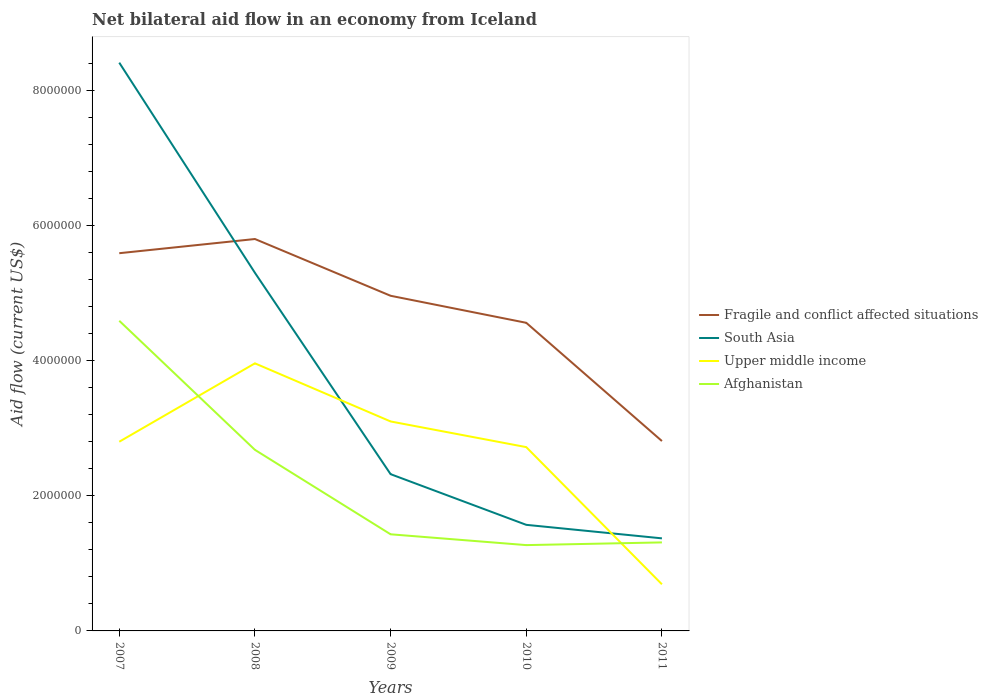How many different coloured lines are there?
Offer a terse response. 4. Does the line corresponding to South Asia intersect with the line corresponding to Fragile and conflict affected situations?
Offer a very short reply. Yes. Is the number of lines equal to the number of legend labels?
Keep it short and to the point. Yes. Across all years, what is the maximum net bilateral aid flow in Upper middle income?
Offer a very short reply. 6.90e+05. In which year was the net bilateral aid flow in Afghanistan maximum?
Ensure brevity in your answer.  2010. What is the total net bilateral aid flow in South Asia in the graph?
Give a very brief answer. 6.09e+06. What is the difference between the highest and the second highest net bilateral aid flow in South Asia?
Your answer should be compact. 7.04e+06. Is the net bilateral aid flow in Fragile and conflict affected situations strictly greater than the net bilateral aid flow in South Asia over the years?
Keep it short and to the point. No. How many lines are there?
Give a very brief answer. 4. How many years are there in the graph?
Keep it short and to the point. 5. Are the values on the major ticks of Y-axis written in scientific E-notation?
Ensure brevity in your answer.  No. Does the graph contain any zero values?
Offer a very short reply. No. Does the graph contain grids?
Your response must be concise. No. Where does the legend appear in the graph?
Ensure brevity in your answer.  Center right. How many legend labels are there?
Your answer should be very brief. 4. What is the title of the graph?
Your answer should be very brief. Net bilateral aid flow in an economy from Iceland. What is the label or title of the Y-axis?
Your response must be concise. Aid flow (current US$). What is the Aid flow (current US$) of Fragile and conflict affected situations in 2007?
Keep it short and to the point. 5.59e+06. What is the Aid flow (current US$) in South Asia in 2007?
Provide a short and direct response. 8.41e+06. What is the Aid flow (current US$) in Upper middle income in 2007?
Provide a succinct answer. 2.80e+06. What is the Aid flow (current US$) in Afghanistan in 2007?
Offer a very short reply. 4.59e+06. What is the Aid flow (current US$) in Fragile and conflict affected situations in 2008?
Your answer should be very brief. 5.80e+06. What is the Aid flow (current US$) of South Asia in 2008?
Keep it short and to the point. 5.30e+06. What is the Aid flow (current US$) in Upper middle income in 2008?
Your response must be concise. 3.96e+06. What is the Aid flow (current US$) in Afghanistan in 2008?
Keep it short and to the point. 2.68e+06. What is the Aid flow (current US$) of Fragile and conflict affected situations in 2009?
Offer a very short reply. 4.96e+06. What is the Aid flow (current US$) of South Asia in 2009?
Your answer should be very brief. 2.32e+06. What is the Aid flow (current US$) of Upper middle income in 2009?
Your response must be concise. 3.10e+06. What is the Aid flow (current US$) of Afghanistan in 2009?
Provide a short and direct response. 1.43e+06. What is the Aid flow (current US$) of Fragile and conflict affected situations in 2010?
Your response must be concise. 4.56e+06. What is the Aid flow (current US$) of South Asia in 2010?
Offer a very short reply. 1.57e+06. What is the Aid flow (current US$) in Upper middle income in 2010?
Keep it short and to the point. 2.72e+06. What is the Aid flow (current US$) in Afghanistan in 2010?
Your answer should be very brief. 1.27e+06. What is the Aid flow (current US$) in Fragile and conflict affected situations in 2011?
Keep it short and to the point. 2.81e+06. What is the Aid flow (current US$) in South Asia in 2011?
Keep it short and to the point. 1.37e+06. What is the Aid flow (current US$) in Upper middle income in 2011?
Keep it short and to the point. 6.90e+05. What is the Aid flow (current US$) in Afghanistan in 2011?
Provide a succinct answer. 1.31e+06. Across all years, what is the maximum Aid flow (current US$) in Fragile and conflict affected situations?
Offer a terse response. 5.80e+06. Across all years, what is the maximum Aid flow (current US$) in South Asia?
Provide a succinct answer. 8.41e+06. Across all years, what is the maximum Aid flow (current US$) of Upper middle income?
Give a very brief answer. 3.96e+06. Across all years, what is the maximum Aid flow (current US$) of Afghanistan?
Your answer should be compact. 4.59e+06. Across all years, what is the minimum Aid flow (current US$) in Fragile and conflict affected situations?
Provide a succinct answer. 2.81e+06. Across all years, what is the minimum Aid flow (current US$) in South Asia?
Ensure brevity in your answer.  1.37e+06. Across all years, what is the minimum Aid flow (current US$) of Upper middle income?
Your response must be concise. 6.90e+05. Across all years, what is the minimum Aid flow (current US$) of Afghanistan?
Ensure brevity in your answer.  1.27e+06. What is the total Aid flow (current US$) of Fragile and conflict affected situations in the graph?
Your answer should be compact. 2.37e+07. What is the total Aid flow (current US$) of South Asia in the graph?
Offer a very short reply. 1.90e+07. What is the total Aid flow (current US$) of Upper middle income in the graph?
Make the answer very short. 1.33e+07. What is the total Aid flow (current US$) of Afghanistan in the graph?
Provide a succinct answer. 1.13e+07. What is the difference between the Aid flow (current US$) of South Asia in 2007 and that in 2008?
Your answer should be very brief. 3.11e+06. What is the difference between the Aid flow (current US$) of Upper middle income in 2007 and that in 2008?
Ensure brevity in your answer.  -1.16e+06. What is the difference between the Aid flow (current US$) of Afghanistan in 2007 and that in 2008?
Make the answer very short. 1.91e+06. What is the difference between the Aid flow (current US$) of Fragile and conflict affected situations in 2007 and that in 2009?
Offer a very short reply. 6.30e+05. What is the difference between the Aid flow (current US$) in South Asia in 2007 and that in 2009?
Ensure brevity in your answer.  6.09e+06. What is the difference between the Aid flow (current US$) of Upper middle income in 2007 and that in 2009?
Ensure brevity in your answer.  -3.00e+05. What is the difference between the Aid flow (current US$) of Afghanistan in 2007 and that in 2009?
Your response must be concise. 3.16e+06. What is the difference between the Aid flow (current US$) of Fragile and conflict affected situations in 2007 and that in 2010?
Keep it short and to the point. 1.03e+06. What is the difference between the Aid flow (current US$) of South Asia in 2007 and that in 2010?
Provide a short and direct response. 6.84e+06. What is the difference between the Aid flow (current US$) of Upper middle income in 2007 and that in 2010?
Your answer should be very brief. 8.00e+04. What is the difference between the Aid flow (current US$) in Afghanistan in 2007 and that in 2010?
Provide a short and direct response. 3.32e+06. What is the difference between the Aid flow (current US$) of Fragile and conflict affected situations in 2007 and that in 2011?
Your answer should be very brief. 2.78e+06. What is the difference between the Aid flow (current US$) of South Asia in 2007 and that in 2011?
Offer a very short reply. 7.04e+06. What is the difference between the Aid flow (current US$) of Upper middle income in 2007 and that in 2011?
Ensure brevity in your answer.  2.11e+06. What is the difference between the Aid flow (current US$) of Afghanistan in 2007 and that in 2011?
Ensure brevity in your answer.  3.28e+06. What is the difference between the Aid flow (current US$) of Fragile and conflict affected situations in 2008 and that in 2009?
Provide a short and direct response. 8.40e+05. What is the difference between the Aid flow (current US$) of South Asia in 2008 and that in 2009?
Your response must be concise. 2.98e+06. What is the difference between the Aid flow (current US$) in Upper middle income in 2008 and that in 2009?
Ensure brevity in your answer.  8.60e+05. What is the difference between the Aid flow (current US$) of Afghanistan in 2008 and that in 2009?
Your answer should be compact. 1.25e+06. What is the difference between the Aid flow (current US$) in Fragile and conflict affected situations in 2008 and that in 2010?
Your response must be concise. 1.24e+06. What is the difference between the Aid flow (current US$) in South Asia in 2008 and that in 2010?
Your answer should be compact. 3.73e+06. What is the difference between the Aid flow (current US$) of Upper middle income in 2008 and that in 2010?
Provide a succinct answer. 1.24e+06. What is the difference between the Aid flow (current US$) of Afghanistan in 2008 and that in 2010?
Make the answer very short. 1.41e+06. What is the difference between the Aid flow (current US$) of Fragile and conflict affected situations in 2008 and that in 2011?
Your answer should be compact. 2.99e+06. What is the difference between the Aid flow (current US$) in South Asia in 2008 and that in 2011?
Offer a very short reply. 3.93e+06. What is the difference between the Aid flow (current US$) in Upper middle income in 2008 and that in 2011?
Ensure brevity in your answer.  3.27e+06. What is the difference between the Aid flow (current US$) of Afghanistan in 2008 and that in 2011?
Your answer should be compact. 1.37e+06. What is the difference between the Aid flow (current US$) of Fragile and conflict affected situations in 2009 and that in 2010?
Ensure brevity in your answer.  4.00e+05. What is the difference between the Aid flow (current US$) in South Asia in 2009 and that in 2010?
Ensure brevity in your answer.  7.50e+05. What is the difference between the Aid flow (current US$) in Afghanistan in 2009 and that in 2010?
Provide a short and direct response. 1.60e+05. What is the difference between the Aid flow (current US$) of Fragile and conflict affected situations in 2009 and that in 2011?
Your answer should be very brief. 2.15e+06. What is the difference between the Aid flow (current US$) of South Asia in 2009 and that in 2011?
Offer a terse response. 9.50e+05. What is the difference between the Aid flow (current US$) in Upper middle income in 2009 and that in 2011?
Your response must be concise. 2.41e+06. What is the difference between the Aid flow (current US$) of Fragile and conflict affected situations in 2010 and that in 2011?
Ensure brevity in your answer.  1.75e+06. What is the difference between the Aid flow (current US$) in Upper middle income in 2010 and that in 2011?
Make the answer very short. 2.03e+06. What is the difference between the Aid flow (current US$) in Afghanistan in 2010 and that in 2011?
Ensure brevity in your answer.  -4.00e+04. What is the difference between the Aid flow (current US$) in Fragile and conflict affected situations in 2007 and the Aid flow (current US$) in Upper middle income in 2008?
Your answer should be very brief. 1.63e+06. What is the difference between the Aid flow (current US$) of Fragile and conflict affected situations in 2007 and the Aid flow (current US$) of Afghanistan in 2008?
Make the answer very short. 2.91e+06. What is the difference between the Aid flow (current US$) in South Asia in 2007 and the Aid flow (current US$) in Upper middle income in 2008?
Give a very brief answer. 4.45e+06. What is the difference between the Aid flow (current US$) in South Asia in 2007 and the Aid flow (current US$) in Afghanistan in 2008?
Offer a very short reply. 5.73e+06. What is the difference between the Aid flow (current US$) in Fragile and conflict affected situations in 2007 and the Aid flow (current US$) in South Asia in 2009?
Provide a succinct answer. 3.27e+06. What is the difference between the Aid flow (current US$) of Fragile and conflict affected situations in 2007 and the Aid flow (current US$) of Upper middle income in 2009?
Your answer should be compact. 2.49e+06. What is the difference between the Aid flow (current US$) of Fragile and conflict affected situations in 2007 and the Aid flow (current US$) of Afghanistan in 2009?
Keep it short and to the point. 4.16e+06. What is the difference between the Aid flow (current US$) of South Asia in 2007 and the Aid flow (current US$) of Upper middle income in 2009?
Make the answer very short. 5.31e+06. What is the difference between the Aid flow (current US$) in South Asia in 2007 and the Aid flow (current US$) in Afghanistan in 2009?
Offer a terse response. 6.98e+06. What is the difference between the Aid flow (current US$) in Upper middle income in 2007 and the Aid flow (current US$) in Afghanistan in 2009?
Provide a succinct answer. 1.37e+06. What is the difference between the Aid flow (current US$) of Fragile and conflict affected situations in 2007 and the Aid flow (current US$) of South Asia in 2010?
Make the answer very short. 4.02e+06. What is the difference between the Aid flow (current US$) in Fragile and conflict affected situations in 2007 and the Aid flow (current US$) in Upper middle income in 2010?
Give a very brief answer. 2.87e+06. What is the difference between the Aid flow (current US$) in Fragile and conflict affected situations in 2007 and the Aid flow (current US$) in Afghanistan in 2010?
Keep it short and to the point. 4.32e+06. What is the difference between the Aid flow (current US$) in South Asia in 2007 and the Aid flow (current US$) in Upper middle income in 2010?
Provide a short and direct response. 5.69e+06. What is the difference between the Aid flow (current US$) of South Asia in 2007 and the Aid flow (current US$) of Afghanistan in 2010?
Your response must be concise. 7.14e+06. What is the difference between the Aid flow (current US$) of Upper middle income in 2007 and the Aid flow (current US$) of Afghanistan in 2010?
Your answer should be compact. 1.53e+06. What is the difference between the Aid flow (current US$) in Fragile and conflict affected situations in 2007 and the Aid flow (current US$) in South Asia in 2011?
Your answer should be very brief. 4.22e+06. What is the difference between the Aid flow (current US$) in Fragile and conflict affected situations in 2007 and the Aid flow (current US$) in Upper middle income in 2011?
Your answer should be very brief. 4.90e+06. What is the difference between the Aid flow (current US$) of Fragile and conflict affected situations in 2007 and the Aid flow (current US$) of Afghanistan in 2011?
Make the answer very short. 4.28e+06. What is the difference between the Aid flow (current US$) of South Asia in 2007 and the Aid flow (current US$) of Upper middle income in 2011?
Your answer should be very brief. 7.72e+06. What is the difference between the Aid flow (current US$) in South Asia in 2007 and the Aid flow (current US$) in Afghanistan in 2011?
Your response must be concise. 7.10e+06. What is the difference between the Aid flow (current US$) of Upper middle income in 2007 and the Aid flow (current US$) of Afghanistan in 2011?
Offer a very short reply. 1.49e+06. What is the difference between the Aid flow (current US$) in Fragile and conflict affected situations in 2008 and the Aid flow (current US$) in South Asia in 2009?
Offer a terse response. 3.48e+06. What is the difference between the Aid flow (current US$) of Fragile and conflict affected situations in 2008 and the Aid flow (current US$) of Upper middle income in 2009?
Provide a short and direct response. 2.70e+06. What is the difference between the Aid flow (current US$) in Fragile and conflict affected situations in 2008 and the Aid flow (current US$) in Afghanistan in 2009?
Offer a terse response. 4.37e+06. What is the difference between the Aid flow (current US$) in South Asia in 2008 and the Aid flow (current US$) in Upper middle income in 2009?
Make the answer very short. 2.20e+06. What is the difference between the Aid flow (current US$) in South Asia in 2008 and the Aid flow (current US$) in Afghanistan in 2009?
Give a very brief answer. 3.87e+06. What is the difference between the Aid flow (current US$) of Upper middle income in 2008 and the Aid flow (current US$) of Afghanistan in 2009?
Keep it short and to the point. 2.53e+06. What is the difference between the Aid flow (current US$) in Fragile and conflict affected situations in 2008 and the Aid flow (current US$) in South Asia in 2010?
Make the answer very short. 4.23e+06. What is the difference between the Aid flow (current US$) of Fragile and conflict affected situations in 2008 and the Aid flow (current US$) of Upper middle income in 2010?
Offer a very short reply. 3.08e+06. What is the difference between the Aid flow (current US$) in Fragile and conflict affected situations in 2008 and the Aid flow (current US$) in Afghanistan in 2010?
Provide a succinct answer. 4.53e+06. What is the difference between the Aid flow (current US$) in South Asia in 2008 and the Aid flow (current US$) in Upper middle income in 2010?
Make the answer very short. 2.58e+06. What is the difference between the Aid flow (current US$) in South Asia in 2008 and the Aid flow (current US$) in Afghanistan in 2010?
Provide a short and direct response. 4.03e+06. What is the difference between the Aid flow (current US$) in Upper middle income in 2008 and the Aid flow (current US$) in Afghanistan in 2010?
Your response must be concise. 2.69e+06. What is the difference between the Aid flow (current US$) in Fragile and conflict affected situations in 2008 and the Aid flow (current US$) in South Asia in 2011?
Provide a short and direct response. 4.43e+06. What is the difference between the Aid flow (current US$) of Fragile and conflict affected situations in 2008 and the Aid flow (current US$) of Upper middle income in 2011?
Give a very brief answer. 5.11e+06. What is the difference between the Aid flow (current US$) of Fragile and conflict affected situations in 2008 and the Aid flow (current US$) of Afghanistan in 2011?
Your answer should be compact. 4.49e+06. What is the difference between the Aid flow (current US$) in South Asia in 2008 and the Aid flow (current US$) in Upper middle income in 2011?
Provide a short and direct response. 4.61e+06. What is the difference between the Aid flow (current US$) of South Asia in 2008 and the Aid flow (current US$) of Afghanistan in 2011?
Your response must be concise. 3.99e+06. What is the difference between the Aid flow (current US$) in Upper middle income in 2008 and the Aid flow (current US$) in Afghanistan in 2011?
Offer a very short reply. 2.65e+06. What is the difference between the Aid flow (current US$) in Fragile and conflict affected situations in 2009 and the Aid flow (current US$) in South Asia in 2010?
Ensure brevity in your answer.  3.39e+06. What is the difference between the Aid flow (current US$) of Fragile and conflict affected situations in 2009 and the Aid flow (current US$) of Upper middle income in 2010?
Ensure brevity in your answer.  2.24e+06. What is the difference between the Aid flow (current US$) in Fragile and conflict affected situations in 2009 and the Aid flow (current US$) in Afghanistan in 2010?
Offer a very short reply. 3.69e+06. What is the difference between the Aid flow (current US$) in South Asia in 2009 and the Aid flow (current US$) in Upper middle income in 2010?
Your answer should be very brief. -4.00e+05. What is the difference between the Aid flow (current US$) in South Asia in 2009 and the Aid flow (current US$) in Afghanistan in 2010?
Give a very brief answer. 1.05e+06. What is the difference between the Aid flow (current US$) of Upper middle income in 2009 and the Aid flow (current US$) of Afghanistan in 2010?
Your answer should be compact. 1.83e+06. What is the difference between the Aid flow (current US$) of Fragile and conflict affected situations in 2009 and the Aid flow (current US$) of South Asia in 2011?
Your answer should be very brief. 3.59e+06. What is the difference between the Aid flow (current US$) of Fragile and conflict affected situations in 2009 and the Aid flow (current US$) of Upper middle income in 2011?
Offer a very short reply. 4.27e+06. What is the difference between the Aid flow (current US$) of Fragile and conflict affected situations in 2009 and the Aid flow (current US$) of Afghanistan in 2011?
Keep it short and to the point. 3.65e+06. What is the difference between the Aid flow (current US$) of South Asia in 2009 and the Aid flow (current US$) of Upper middle income in 2011?
Keep it short and to the point. 1.63e+06. What is the difference between the Aid flow (current US$) of South Asia in 2009 and the Aid flow (current US$) of Afghanistan in 2011?
Offer a very short reply. 1.01e+06. What is the difference between the Aid flow (current US$) of Upper middle income in 2009 and the Aid flow (current US$) of Afghanistan in 2011?
Offer a very short reply. 1.79e+06. What is the difference between the Aid flow (current US$) in Fragile and conflict affected situations in 2010 and the Aid flow (current US$) in South Asia in 2011?
Your answer should be compact. 3.19e+06. What is the difference between the Aid flow (current US$) in Fragile and conflict affected situations in 2010 and the Aid flow (current US$) in Upper middle income in 2011?
Keep it short and to the point. 3.87e+06. What is the difference between the Aid flow (current US$) in Fragile and conflict affected situations in 2010 and the Aid flow (current US$) in Afghanistan in 2011?
Your answer should be compact. 3.25e+06. What is the difference between the Aid flow (current US$) of South Asia in 2010 and the Aid flow (current US$) of Upper middle income in 2011?
Your response must be concise. 8.80e+05. What is the difference between the Aid flow (current US$) in South Asia in 2010 and the Aid flow (current US$) in Afghanistan in 2011?
Your answer should be compact. 2.60e+05. What is the difference between the Aid flow (current US$) of Upper middle income in 2010 and the Aid flow (current US$) of Afghanistan in 2011?
Your answer should be compact. 1.41e+06. What is the average Aid flow (current US$) in Fragile and conflict affected situations per year?
Give a very brief answer. 4.74e+06. What is the average Aid flow (current US$) in South Asia per year?
Ensure brevity in your answer.  3.79e+06. What is the average Aid flow (current US$) of Upper middle income per year?
Keep it short and to the point. 2.65e+06. What is the average Aid flow (current US$) of Afghanistan per year?
Your response must be concise. 2.26e+06. In the year 2007, what is the difference between the Aid flow (current US$) in Fragile and conflict affected situations and Aid flow (current US$) in South Asia?
Offer a terse response. -2.82e+06. In the year 2007, what is the difference between the Aid flow (current US$) in Fragile and conflict affected situations and Aid flow (current US$) in Upper middle income?
Provide a short and direct response. 2.79e+06. In the year 2007, what is the difference between the Aid flow (current US$) of South Asia and Aid flow (current US$) of Upper middle income?
Offer a terse response. 5.61e+06. In the year 2007, what is the difference between the Aid flow (current US$) of South Asia and Aid flow (current US$) of Afghanistan?
Your answer should be compact. 3.82e+06. In the year 2007, what is the difference between the Aid flow (current US$) of Upper middle income and Aid flow (current US$) of Afghanistan?
Provide a short and direct response. -1.79e+06. In the year 2008, what is the difference between the Aid flow (current US$) of Fragile and conflict affected situations and Aid flow (current US$) of Upper middle income?
Offer a very short reply. 1.84e+06. In the year 2008, what is the difference between the Aid flow (current US$) in Fragile and conflict affected situations and Aid flow (current US$) in Afghanistan?
Make the answer very short. 3.12e+06. In the year 2008, what is the difference between the Aid flow (current US$) of South Asia and Aid flow (current US$) of Upper middle income?
Provide a short and direct response. 1.34e+06. In the year 2008, what is the difference between the Aid flow (current US$) of South Asia and Aid flow (current US$) of Afghanistan?
Provide a short and direct response. 2.62e+06. In the year 2008, what is the difference between the Aid flow (current US$) in Upper middle income and Aid flow (current US$) in Afghanistan?
Provide a succinct answer. 1.28e+06. In the year 2009, what is the difference between the Aid flow (current US$) in Fragile and conflict affected situations and Aid flow (current US$) in South Asia?
Keep it short and to the point. 2.64e+06. In the year 2009, what is the difference between the Aid flow (current US$) of Fragile and conflict affected situations and Aid flow (current US$) of Upper middle income?
Your response must be concise. 1.86e+06. In the year 2009, what is the difference between the Aid flow (current US$) in Fragile and conflict affected situations and Aid flow (current US$) in Afghanistan?
Offer a terse response. 3.53e+06. In the year 2009, what is the difference between the Aid flow (current US$) in South Asia and Aid flow (current US$) in Upper middle income?
Give a very brief answer. -7.80e+05. In the year 2009, what is the difference between the Aid flow (current US$) of South Asia and Aid flow (current US$) of Afghanistan?
Your answer should be compact. 8.90e+05. In the year 2009, what is the difference between the Aid flow (current US$) of Upper middle income and Aid flow (current US$) of Afghanistan?
Offer a terse response. 1.67e+06. In the year 2010, what is the difference between the Aid flow (current US$) in Fragile and conflict affected situations and Aid flow (current US$) in South Asia?
Keep it short and to the point. 2.99e+06. In the year 2010, what is the difference between the Aid flow (current US$) of Fragile and conflict affected situations and Aid flow (current US$) of Upper middle income?
Your answer should be compact. 1.84e+06. In the year 2010, what is the difference between the Aid flow (current US$) in Fragile and conflict affected situations and Aid flow (current US$) in Afghanistan?
Your answer should be very brief. 3.29e+06. In the year 2010, what is the difference between the Aid flow (current US$) of South Asia and Aid flow (current US$) of Upper middle income?
Keep it short and to the point. -1.15e+06. In the year 2010, what is the difference between the Aid flow (current US$) of South Asia and Aid flow (current US$) of Afghanistan?
Keep it short and to the point. 3.00e+05. In the year 2010, what is the difference between the Aid flow (current US$) in Upper middle income and Aid flow (current US$) in Afghanistan?
Provide a succinct answer. 1.45e+06. In the year 2011, what is the difference between the Aid flow (current US$) in Fragile and conflict affected situations and Aid flow (current US$) in South Asia?
Provide a succinct answer. 1.44e+06. In the year 2011, what is the difference between the Aid flow (current US$) of Fragile and conflict affected situations and Aid flow (current US$) of Upper middle income?
Give a very brief answer. 2.12e+06. In the year 2011, what is the difference between the Aid flow (current US$) in Fragile and conflict affected situations and Aid flow (current US$) in Afghanistan?
Offer a terse response. 1.50e+06. In the year 2011, what is the difference between the Aid flow (current US$) of South Asia and Aid flow (current US$) of Upper middle income?
Provide a succinct answer. 6.80e+05. In the year 2011, what is the difference between the Aid flow (current US$) of Upper middle income and Aid flow (current US$) of Afghanistan?
Provide a short and direct response. -6.20e+05. What is the ratio of the Aid flow (current US$) in Fragile and conflict affected situations in 2007 to that in 2008?
Offer a terse response. 0.96. What is the ratio of the Aid flow (current US$) in South Asia in 2007 to that in 2008?
Make the answer very short. 1.59. What is the ratio of the Aid flow (current US$) of Upper middle income in 2007 to that in 2008?
Your response must be concise. 0.71. What is the ratio of the Aid flow (current US$) of Afghanistan in 2007 to that in 2008?
Keep it short and to the point. 1.71. What is the ratio of the Aid flow (current US$) in Fragile and conflict affected situations in 2007 to that in 2009?
Ensure brevity in your answer.  1.13. What is the ratio of the Aid flow (current US$) in South Asia in 2007 to that in 2009?
Offer a terse response. 3.62. What is the ratio of the Aid flow (current US$) in Upper middle income in 2007 to that in 2009?
Make the answer very short. 0.9. What is the ratio of the Aid flow (current US$) in Afghanistan in 2007 to that in 2009?
Ensure brevity in your answer.  3.21. What is the ratio of the Aid flow (current US$) of Fragile and conflict affected situations in 2007 to that in 2010?
Ensure brevity in your answer.  1.23. What is the ratio of the Aid flow (current US$) in South Asia in 2007 to that in 2010?
Keep it short and to the point. 5.36. What is the ratio of the Aid flow (current US$) of Upper middle income in 2007 to that in 2010?
Offer a terse response. 1.03. What is the ratio of the Aid flow (current US$) of Afghanistan in 2007 to that in 2010?
Make the answer very short. 3.61. What is the ratio of the Aid flow (current US$) of Fragile and conflict affected situations in 2007 to that in 2011?
Make the answer very short. 1.99. What is the ratio of the Aid flow (current US$) of South Asia in 2007 to that in 2011?
Provide a short and direct response. 6.14. What is the ratio of the Aid flow (current US$) in Upper middle income in 2007 to that in 2011?
Your answer should be very brief. 4.06. What is the ratio of the Aid flow (current US$) of Afghanistan in 2007 to that in 2011?
Provide a succinct answer. 3.5. What is the ratio of the Aid flow (current US$) in Fragile and conflict affected situations in 2008 to that in 2009?
Provide a succinct answer. 1.17. What is the ratio of the Aid flow (current US$) of South Asia in 2008 to that in 2009?
Keep it short and to the point. 2.28. What is the ratio of the Aid flow (current US$) in Upper middle income in 2008 to that in 2009?
Provide a succinct answer. 1.28. What is the ratio of the Aid flow (current US$) of Afghanistan in 2008 to that in 2009?
Ensure brevity in your answer.  1.87. What is the ratio of the Aid flow (current US$) of Fragile and conflict affected situations in 2008 to that in 2010?
Offer a terse response. 1.27. What is the ratio of the Aid flow (current US$) in South Asia in 2008 to that in 2010?
Provide a short and direct response. 3.38. What is the ratio of the Aid flow (current US$) in Upper middle income in 2008 to that in 2010?
Your answer should be compact. 1.46. What is the ratio of the Aid flow (current US$) in Afghanistan in 2008 to that in 2010?
Give a very brief answer. 2.11. What is the ratio of the Aid flow (current US$) of Fragile and conflict affected situations in 2008 to that in 2011?
Provide a short and direct response. 2.06. What is the ratio of the Aid flow (current US$) of South Asia in 2008 to that in 2011?
Provide a short and direct response. 3.87. What is the ratio of the Aid flow (current US$) in Upper middle income in 2008 to that in 2011?
Keep it short and to the point. 5.74. What is the ratio of the Aid flow (current US$) in Afghanistan in 2008 to that in 2011?
Ensure brevity in your answer.  2.05. What is the ratio of the Aid flow (current US$) of Fragile and conflict affected situations in 2009 to that in 2010?
Offer a terse response. 1.09. What is the ratio of the Aid flow (current US$) of South Asia in 2009 to that in 2010?
Ensure brevity in your answer.  1.48. What is the ratio of the Aid flow (current US$) of Upper middle income in 2009 to that in 2010?
Give a very brief answer. 1.14. What is the ratio of the Aid flow (current US$) of Afghanistan in 2009 to that in 2010?
Your answer should be very brief. 1.13. What is the ratio of the Aid flow (current US$) in Fragile and conflict affected situations in 2009 to that in 2011?
Ensure brevity in your answer.  1.77. What is the ratio of the Aid flow (current US$) of South Asia in 2009 to that in 2011?
Provide a short and direct response. 1.69. What is the ratio of the Aid flow (current US$) of Upper middle income in 2009 to that in 2011?
Provide a succinct answer. 4.49. What is the ratio of the Aid flow (current US$) in Afghanistan in 2009 to that in 2011?
Keep it short and to the point. 1.09. What is the ratio of the Aid flow (current US$) of Fragile and conflict affected situations in 2010 to that in 2011?
Make the answer very short. 1.62. What is the ratio of the Aid flow (current US$) of South Asia in 2010 to that in 2011?
Provide a succinct answer. 1.15. What is the ratio of the Aid flow (current US$) of Upper middle income in 2010 to that in 2011?
Offer a terse response. 3.94. What is the ratio of the Aid flow (current US$) of Afghanistan in 2010 to that in 2011?
Offer a very short reply. 0.97. What is the difference between the highest and the second highest Aid flow (current US$) in Fragile and conflict affected situations?
Give a very brief answer. 2.10e+05. What is the difference between the highest and the second highest Aid flow (current US$) of South Asia?
Provide a succinct answer. 3.11e+06. What is the difference between the highest and the second highest Aid flow (current US$) in Upper middle income?
Provide a short and direct response. 8.60e+05. What is the difference between the highest and the second highest Aid flow (current US$) of Afghanistan?
Offer a terse response. 1.91e+06. What is the difference between the highest and the lowest Aid flow (current US$) in Fragile and conflict affected situations?
Keep it short and to the point. 2.99e+06. What is the difference between the highest and the lowest Aid flow (current US$) of South Asia?
Your answer should be very brief. 7.04e+06. What is the difference between the highest and the lowest Aid flow (current US$) in Upper middle income?
Offer a terse response. 3.27e+06. What is the difference between the highest and the lowest Aid flow (current US$) of Afghanistan?
Offer a very short reply. 3.32e+06. 